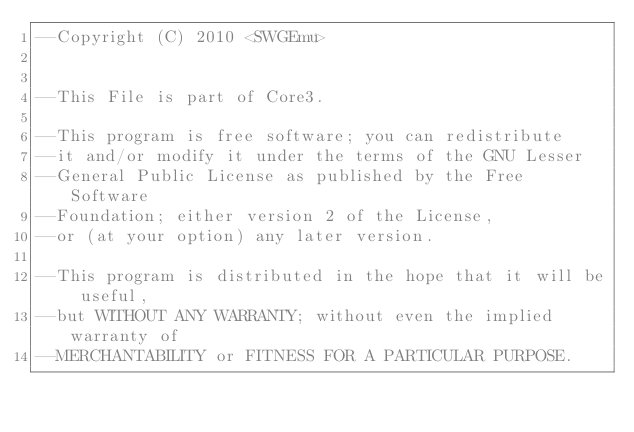<code> <loc_0><loc_0><loc_500><loc_500><_Lua_>--Copyright (C) 2010 <SWGEmu>


--This File is part of Core3.

--This program is free software; you can redistribute 
--it and/or modify it under the terms of the GNU Lesser 
--General Public License as published by the Free Software
--Foundation; either version 2 of the License, 
--or (at your option) any later version.

--This program is distributed in the hope that it will be useful, 
--but WITHOUT ANY WARRANTY; without even the implied warranty of 
--MERCHANTABILITY or FITNESS FOR A PARTICULAR PURPOSE. </code> 